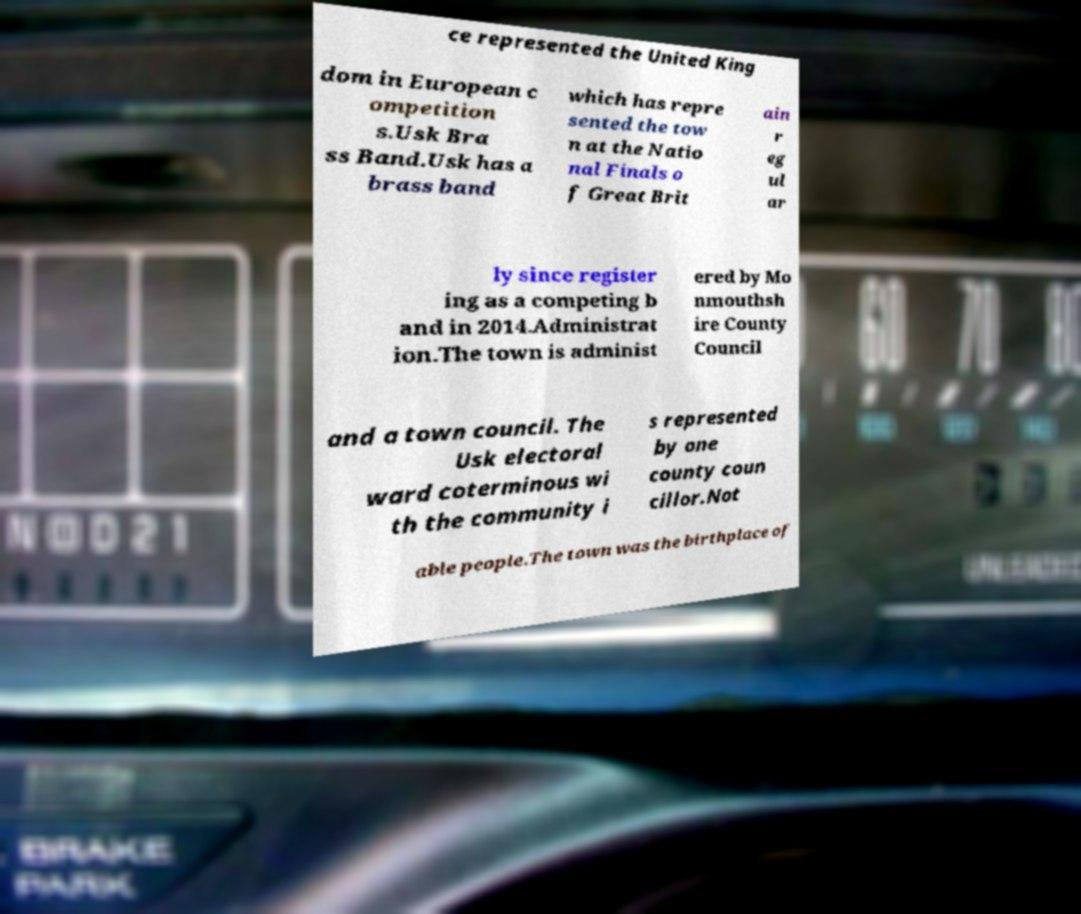I need the written content from this picture converted into text. Can you do that? ce represented the United King dom in European c ompetition s.Usk Bra ss Band.Usk has a brass band which has repre sented the tow n at the Natio nal Finals o f Great Brit ain r eg ul ar ly since register ing as a competing b and in 2014.Administrat ion.The town is administ ered by Mo nmouthsh ire County Council and a town council. The Usk electoral ward coterminous wi th the community i s represented by one county coun cillor.Not able people.The town was the birthplace of 